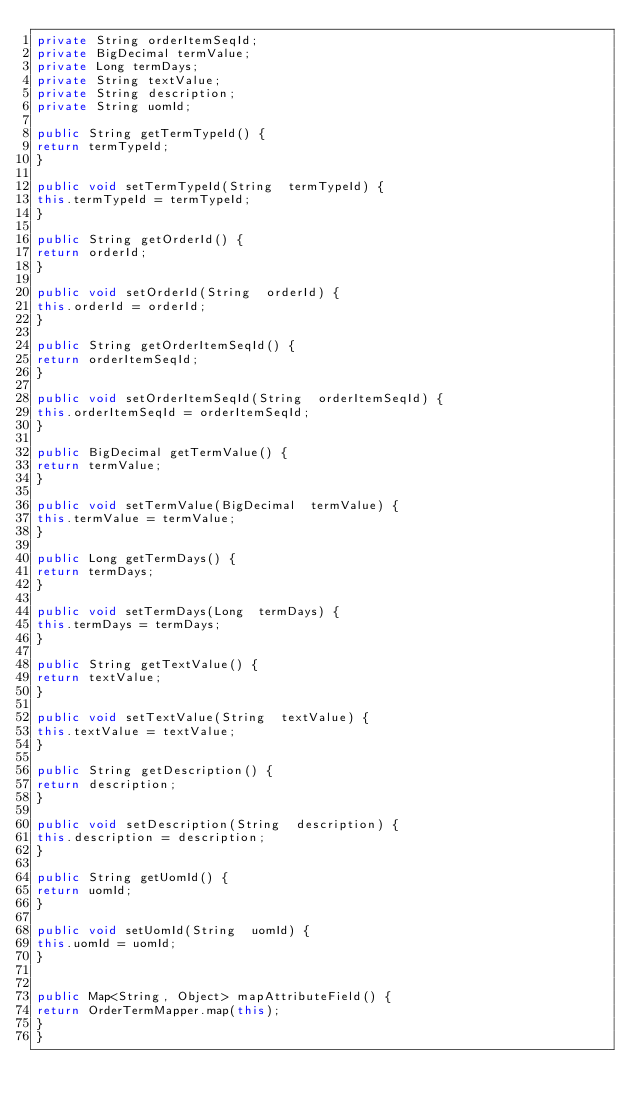<code> <loc_0><loc_0><loc_500><loc_500><_Java_>private String orderItemSeqId;
private BigDecimal termValue;
private Long termDays;
private String textValue;
private String description;
private String uomId;

public String getTermTypeId() {
return termTypeId;
}

public void setTermTypeId(String  termTypeId) {
this.termTypeId = termTypeId;
}

public String getOrderId() {
return orderId;
}

public void setOrderId(String  orderId) {
this.orderId = orderId;
}

public String getOrderItemSeqId() {
return orderItemSeqId;
}

public void setOrderItemSeqId(String  orderItemSeqId) {
this.orderItemSeqId = orderItemSeqId;
}

public BigDecimal getTermValue() {
return termValue;
}

public void setTermValue(BigDecimal  termValue) {
this.termValue = termValue;
}

public Long getTermDays() {
return termDays;
}

public void setTermDays(Long  termDays) {
this.termDays = termDays;
}

public String getTextValue() {
return textValue;
}

public void setTextValue(String  textValue) {
this.textValue = textValue;
}

public String getDescription() {
return description;
}

public void setDescription(String  description) {
this.description = description;
}

public String getUomId() {
return uomId;
}

public void setUomId(String  uomId) {
this.uomId = uomId;
}


public Map<String, Object> mapAttributeField() {
return OrderTermMapper.map(this);
}
}
</code> 